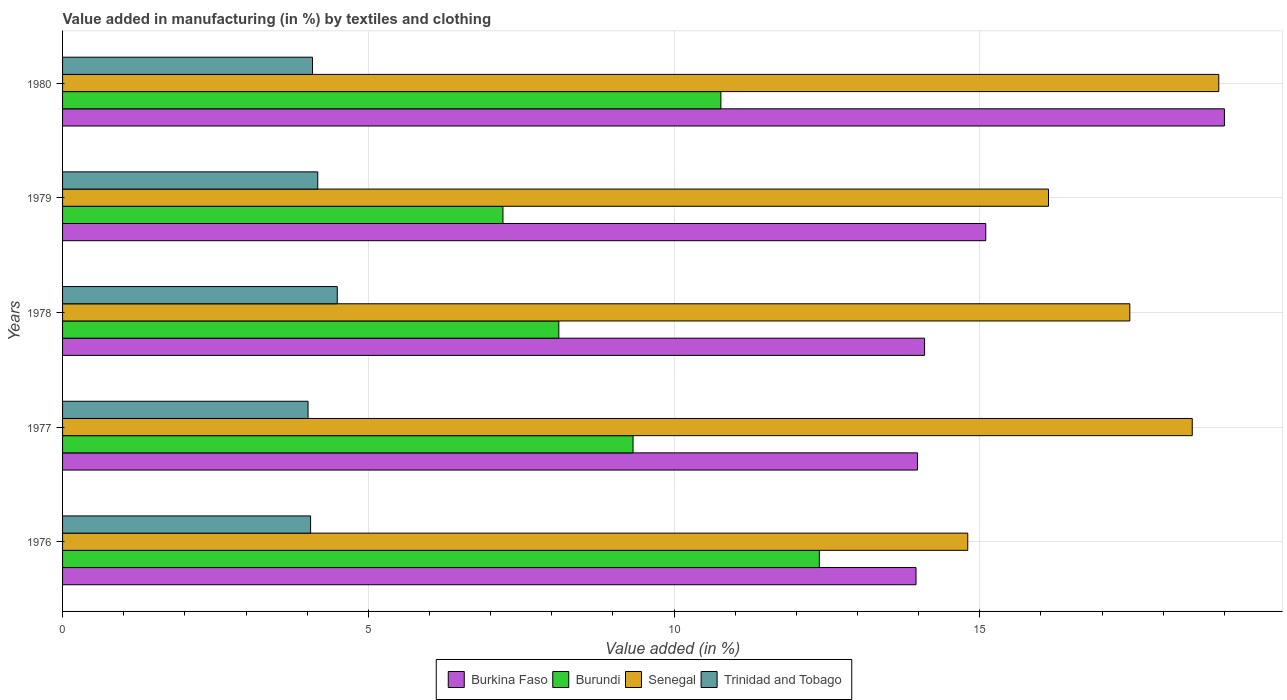How many different coloured bars are there?
Your answer should be compact. 4. Are the number of bars on each tick of the Y-axis equal?
Make the answer very short. Yes. How many bars are there on the 5th tick from the top?
Your response must be concise. 4. What is the label of the 2nd group of bars from the top?
Provide a short and direct response. 1979. In how many cases, is the number of bars for a given year not equal to the number of legend labels?
Your answer should be very brief. 0. What is the percentage of value added in manufacturing by textiles and clothing in Burundi in 1978?
Keep it short and to the point. 8.12. Across all years, what is the maximum percentage of value added in manufacturing by textiles and clothing in Burkina Faso?
Offer a terse response. 19. Across all years, what is the minimum percentage of value added in manufacturing by textiles and clothing in Burkina Faso?
Make the answer very short. 13.96. In which year was the percentage of value added in manufacturing by textiles and clothing in Burkina Faso minimum?
Provide a succinct answer. 1976. What is the total percentage of value added in manufacturing by textiles and clothing in Trinidad and Tobago in the graph?
Provide a short and direct response. 20.82. What is the difference between the percentage of value added in manufacturing by textiles and clothing in Burkina Faso in 1977 and that in 1978?
Make the answer very short. -0.12. What is the difference between the percentage of value added in manufacturing by textiles and clothing in Burkina Faso in 1979 and the percentage of value added in manufacturing by textiles and clothing in Trinidad and Tobago in 1977?
Your answer should be very brief. 11.08. What is the average percentage of value added in manufacturing by textiles and clothing in Burkina Faso per year?
Provide a short and direct response. 15.23. In the year 1978, what is the difference between the percentage of value added in manufacturing by textiles and clothing in Burkina Faso and percentage of value added in manufacturing by textiles and clothing in Trinidad and Tobago?
Give a very brief answer. 9.6. What is the ratio of the percentage of value added in manufacturing by textiles and clothing in Senegal in 1979 to that in 1980?
Keep it short and to the point. 0.85. Is the difference between the percentage of value added in manufacturing by textiles and clothing in Burkina Faso in 1977 and 1979 greater than the difference between the percentage of value added in manufacturing by textiles and clothing in Trinidad and Tobago in 1977 and 1979?
Offer a terse response. No. What is the difference between the highest and the second highest percentage of value added in manufacturing by textiles and clothing in Burundi?
Offer a very short reply. 1.61. What is the difference between the highest and the lowest percentage of value added in manufacturing by textiles and clothing in Burkina Faso?
Give a very brief answer. 5.04. Is the sum of the percentage of value added in manufacturing by textiles and clothing in Trinidad and Tobago in 1976 and 1977 greater than the maximum percentage of value added in manufacturing by textiles and clothing in Senegal across all years?
Provide a succinct answer. No. Is it the case that in every year, the sum of the percentage of value added in manufacturing by textiles and clothing in Trinidad and Tobago and percentage of value added in manufacturing by textiles and clothing in Burundi is greater than the sum of percentage of value added in manufacturing by textiles and clothing in Senegal and percentage of value added in manufacturing by textiles and clothing in Burkina Faso?
Ensure brevity in your answer.  Yes. What does the 4th bar from the top in 1978 represents?
Your answer should be compact. Burkina Faso. What does the 4th bar from the bottom in 1978 represents?
Provide a succinct answer. Trinidad and Tobago. Is it the case that in every year, the sum of the percentage of value added in manufacturing by textiles and clothing in Burundi and percentage of value added in manufacturing by textiles and clothing in Burkina Faso is greater than the percentage of value added in manufacturing by textiles and clothing in Trinidad and Tobago?
Offer a very short reply. Yes. How many bars are there?
Your response must be concise. 20. Are all the bars in the graph horizontal?
Ensure brevity in your answer.  Yes. What is the difference between two consecutive major ticks on the X-axis?
Ensure brevity in your answer.  5. Are the values on the major ticks of X-axis written in scientific E-notation?
Keep it short and to the point. No. Does the graph contain grids?
Your response must be concise. Yes. Where does the legend appear in the graph?
Offer a very short reply. Bottom center. What is the title of the graph?
Provide a short and direct response. Value added in manufacturing (in %) by textiles and clothing. What is the label or title of the X-axis?
Your answer should be very brief. Value added (in %). What is the label or title of the Y-axis?
Provide a short and direct response. Years. What is the Value added (in %) in Burkina Faso in 1976?
Offer a terse response. 13.96. What is the Value added (in %) in Burundi in 1976?
Your answer should be very brief. 12.38. What is the Value added (in %) in Senegal in 1976?
Offer a very short reply. 14.8. What is the Value added (in %) of Trinidad and Tobago in 1976?
Provide a short and direct response. 4.06. What is the Value added (in %) of Burkina Faso in 1977?
Keep it short and to the point. 13.98. What is the Value added (in %) of Burundi in 1977?
Your answer should be very brief. 9.33. What is the Value added (in %) of Senegal in 1977?
Make the answer very short. 18.48. What is the Value added (in %) of Trinidad and Tobago in 1977?
Offer a very short reply. 4.01. What is the Value added (in %) in Burkina Faso in 1978?
Offer a very short reply. 14.1. What is the Value added (in %) of Burundi in 1978?
Ensure brevity in your answer.  8.12. What is the Value added (in %) in Senegal in 1978?
Offer a terse response. 17.45. What is the Value added (in %) of Trinidad and Tobago in 1978?
Offer a terse response. 4.49. What is the Value added (in %) of Burkina Faso in 1979?
Offer a terse response. 15.1. What is the Value added (in %) in Burundi in 1979?
Give a very brief answer. 7.2. What is the Value added (in %) in Senegal in 1979?
Make the answer very short. 16.12. What is the Value added (in %) of Trinidad and Tobago in 1979?
Provide a short and direct response. 4.17. What is the Value added (in %) of Burkina Faso in 1980?
Your response must be concise. 19. What is the Value added (in %) of Burundi in 1980?
Make the answer very short. 10.77. What is the Value added (in %) in Senegal in 1980?
Provide a short and direct response. 18.91. What is the Value added (in %) of Trinidad and Tobago in 1980?
Your answer should be compact. 4.09. Across all years, what is the maximum Value added (in %) in Burkina Faso?
Make the answer very short. 19. Across all years, what is the maximum Value added (in %) in Burundi?
Provide a succinct answer. 12.38. Across all years, what is the maximum Value added (in %) of Senegal?
Ensure brevity in your answer.  18.91. Across all years, what is the maximum Value added (in %) in Trinidad and Tobago?
Ensure brevity in your answer.  4.49. Across all years, what is the minimum Value added (in %) of Burkina Faso?
Provide a succinct answer. 13.96. Across all years, what is the minimum Value added (in %) in Burundi?
Make the answer very short. 7.2. Across all years, what is the minimum Value added (in %) of Senegal?
Offer a terse response. 14.8. Across all years, what is the minimum Value added (in %) of Trinidad and Tobago?
Keep it short and to the point. 4.01. What is the total Value added (in %) of Burkina Faso in the graph?
Ensure brevity in your answer.  76.14. What is the total Value added (in %) of Burundi in the graph?
Give a very brief answer. 47.79. What is the total Value added (in %) in Senegal in the graph?
Provide a succinct answer. 85.77. What is the total Value added (in %) of Trinidad and Tobago in the graph?
Give a very brief answer. 20.82. What is the difference between the Value added (in %) in Burkina Faso in 1976 and that in 1977?
Your answer should be very brief. -0.02. What is the difference between the Value added (in %) in Burundi in 1976 and that in 1977?
Your answer should be compact. 3.05. What is the difference between the Value added (in %) in Senegal in 1976 and that in 1977?
Offer a very short reply. -3.67. What is the difference between the Value added (in %) of Trinidad and Tobago in 1976 and that in 1977?
Make the answer very short. 0.04. What is the difference between the Value added (in %) of Burkina Faso in 1976 and that in 1978?
Provide a short and direct response. -0.14. What is the difference between the Value added (in %) in Burundi in 1976 and that in 1978?
Offer a terse response. 4.26. What is the difference between the Value added (in %) in Senegal in 1976 and that in 1978?
Offer a terse response. -2.65. What is the difference between the Value added (in %) of Trinidad and Tobago in 1976 and that in 1978?
Give a very brief answer. -0.44. What is the difference between the Value added (in %) in Burkina Faso in 1976 and that in 1979?
Your answer should be compact. -1.14. What is the difference between the Value added (in %) in Burundi in 1976 and that in 1979?
Provide a short and direct response. 5.17. What is the difference between the Value added (in %) of Senegal in 1976 and that in 1979?
Offer a very short reply. -1.32. What is the difference between the Value added (in %) of Trinidad and Tobago in 1976 and that in 1979?
Give a very brief answer. -0.12. What is the difference between the Value added (in %) of Burkina Faso in 1976 and that in 1980?
Provide a short and direct response. -5.04. What is the difference between the Value added (in %) of Burundi in 1976 and that in 1980?
Ensure brevity in your answer.  1.61. What is the difference between the Value added (in %) of Senegal in 1976 and that in 1980?
Your answer should be compact. -4.11. What is the difference between the Value added (in %) in Trinidad and Tobago in 1976 and that in 1980?
Your answer should be compact. -0.03. What is the difference between the Value added (in %) in Burkina Faso in 1977 and that in 1978?
Ensure brevity in your answer.  -0.12. What is the difference between the Value added (in %) in Burundi in 1977 and that in 1978?
Provide a short and direct response. 1.21. What is the difference between the Value added (in %) in Senegal in 1977 and that in 1978?
Make the answer very short. 1.02. What is the difference between the Value added (in %) in Trinidad and Tobago in 1977 and that in 1978?
Make the answer very short. -0.48. What is the difference between the Value added (in %) of Burkina Faso in 1977 and that in 1979?
Provide a succinct answer. -1.12. What is the difference between the Value added (in %) of Burundi in 1977 and that in 1979?
Make the answer very short. 2.13. What is the difference between the Value added (in %) of Senegal in 1977 and that in 1979?
Provide a short and direct response. 2.35. What is the difference between the Value added (in %) in Trinidad and Tobago in 1977 and that in 1979?
Ensure brevity in your answer.  -0.16. What is the difference between the Value added (in %) of Burkina Faso in 1977 and that in 1980?
Make the answer very short. -5.02. What is the difference between the Value added (in %) in Burundi in 1977 and that in 1980?
Your answer should be very brief. -1.44. What is the difference between the Value added (in %) of Senegal in 1977 and that in 1980?
Your response must be concise. -0.43. What is the difference between the Value added (in %) of Trinidad and Tobago in 1977 and that in 1980?
Provide a succinct answer. -0.07. What is the difference between the Value added (in %) of Burkina Faso in 1978 and that in 1979?
Offer a terse response. -1. What is the difference between the Value added (in %) in Burundi in 1978 and that in 1979?
Give a very brief answer. 0.91. What is the difference between the Value added (in %) in Senegal in 1978 and that in 1979?
Your answer should be compact. 1.33. What is the difference between the Value added (in %) in Trinidad and Tobago in 1978 and that in 1979?
Give a very brief answer. 0.32. What is the difference between the Value added (in %) of Burkina Faso in 1978 and that in 1980?
Ensure brevity in your answer.  -4.9. What is the difference between the Value added (in %) of Burundi in 1978 and that in 1980?
Your answer should be compact. -2.65. What is the difference between the Value added (in %) of Senegal in 1978 and that in 1980?
Your answer should be very brief. -1.45. What is the difference between the Value added (in %) in Trinidad and Tobago in 1978 and that in 1980?
Keep it short and to the point. 0.41. What is the difference between the Value added (in %) in Burkina Faso in 1979 and that in 1980?
Keep it short and to the point. -3.9. What is the difference between the Value added (in %) in Burundi in 1979 and that in 1980?
Your answer should be very brief. -3.56. What is the difference between the Value added (in %) of Senegal in 1979 and that in 1980?
Keep it short and to the point. -2.78. What is the difference between the Value added (in %) in Trinidad and Tobago in 1979 and that in 1980?
Offer a terse response. 0.09. What is the difference between the Value added (in %) of Burkina Faso in 1976 and the Value added (in %) of Burundi in 1977?
Your answer should be very brief. 4.63. What is the difference between the Value added (in %) of Burkina Faso in 1976 and the Value added (in %) of Senegal in 1977?
Your response must be concise. -4.52. What is the difference between the Value added (in %) of Burkina Faso in 1976 and the Value added (in %) of Trinidad and Tobago in 1977?
Your answer should be very brief. 9.94. What is the difference between the Value added (in %) in Burundi in 1976 and the Value added (in %) in Senegal in 1977?
Your answer should be very brief. -6.1. What is the difference between the Value added (in %) in Burundi in 1976 and the Value added (in %) in Trinidad and Tobago in 1977?
Ensure brevity in your answer.  8.36. What is the difference between the Value added (in %) in Senegal in 1976 and the Value added (in %) in Trinidad and Tobago in 1977?
Offer a very short reply. 10.79. What is the difference between the Value added (in %) in Burkina Faso in 1976 and the Value added (in %) in Burundi in 1978?
Ensure brevity in your answer.  5.84. What is the difference between the Value added (in %) in Burkina Faso in 1976 and the Value added (in %) in Senegal in 1978?
Your answer should be very brief. -3.5. What is the difference between the Value added (in %) in Burkina Faso in 1976 and the Value added (in %) in Trinidad and Tobago in 1978?
Keep it short and to the point. 9.47. What is the difference between the Value added (in %) of Burundi in 1976 and the Value added (in %) of Senegal in 1978?
Provide a short and direct response. -5.08. What is the difference between the Value added (in %) of Burundi in 1976 and the Value added (in %) of Trinidad and Tobago in 1978?
Your answer should be very brief. 7.88. What is the difference between the Value added (in %) of Senegal in 1976 and the Value added (in %) of Trinidad and Tobago in 1978?
Keep it short and to the point. 10.31. What is the difference between the Value added (in %) of Burkina Faso in 1976 and the Value added (in %) of Burundi in 1979?
Give a very brief answer. 6.76. What is the difference between the Value added (in %) in Burkina Faso in 1976 and the Value added (in %) in Senegal in 1979?
Keep it short and to the point. -2.17. What is the difference between the Value added (in %) in Burkina Faso in 1976 and the Value added (in %) in Trinidad and Tobago in 1979?
Your answer should be compact. 9.78. What is the difference between the Value added (in %) in Burundi in 1976 and the Value added (in %) in Senegal in 1979?
Your response must be concise. -3.75. What is the difference between the Value added (in %) of Burundi in 1976 and the Value added (in %) of Trinidad and Tobago in 1979?
Your answer should be very brief. 8.2. What is the difference between the Value added (in %) of Senegal in 1976 and the Value added (in %) of Trinidad and Tobago in 1979?
Your answer should be compact. 10.63. What is the difference between the Value added (in %) of Burkina Faso in 1976 and the Value added (in %) of Burundi in 1980?
Ensure brevity in your answer.  3.19. What is the difference between the Value added (in %) in Burkina Faso in 1976 and the Value added (in %) in Senegal in 1980?
Give a very brief answer. -4.95. What is the difference between the Value added (in %) of Burkina Faso in 1976 and the Value added (in %) of Trinidad and Tobago in 1980?
Give a very brief answer. 9.87. What is the difference between the Value added (in %) of Burundi in 1976 and the Value added (in %) of Senegal in 1980?
Make the answer very short. -6.53. What is the difference between the Value added (in %) in Burundi in 1976 and the Value added (in %) in Trinidad and Tobago in 1980?
Offer a very short reply. 8.29. What is the difference between the Value added (in %) of Senegal in 1976 and the Value added (in %) of Trinidad and Tobago in 1980?
Your response must be concise. 10.72. What is the difference between the Value added (in %) of Burkina Faso in 1977 and the Value added (in %) of Burundi in 1978?
Ensure brevity in your answer.  5.87. What is the difference between the Value added (in %) of Burkina Faso in 1977 and the Value added (in %) of Senegal in 1978?
Your answer should be compact. -3.47. What is the difference between the Value added (in %) of Burkina Faso in 1977 and the Value added (in %) of Trinidad and Tobago in 1978?
Your answer should be compact. 9.49. What is the difference between the Value added (in %) of Burundi in 1977 and the Value added (in %) of Senegal in 1978?
Provide a succinct answer. -8.12. What is the difference between the Value added (in %) in Burundi in 1977 and the Value added (in %) in Trinidad and Tobago in 1978?
Your answer should be compact. 4.84. What is the difference between the Value added (in %) of Senegal in 1977 and the Value added (in %) of Trinidad and Tobago in 1978?
Keep it short and to the point. 13.98. What is the difference between the Value added (in %) of Burkina Faso in 1977 and the Value added (in %) of Burundi in 1979?
Provide a succinct answer. 6.78. What is the difference between the Value added (in %) in Burkina Faso in 1977 and the Value added (in %) in Senegal in 1979?
Give a very brief answer. -2.14. What is the difference between the Value added (in %) of Burkina Faso in 1977 and the Value added (in %) of Trinidad and Tobago in 1979?
Your response must be concise. 9.81. What is the difference between the Value added (in %) in Burundi in 1977 and the Value added (in %) in Senegal in 1979?
Your response must be concise. -6.79. What is the difference between the Value added (in %) of Burundi in 1977 and the Value added (in %) of Trinidad and Tobago in 1979?
Make the answer very short. 5.16. What is the difference between the Value added (in %) of Senegal in 1977 and the Value added (in %) of Trinidad and Tobago in 1979?
Your answer should be very brief. 14.3. What is the difference between the Value added (in %) of Burkina Faso in 1977 and the Value added (in %) of Burundi in 1980?
Keep it short and to the point. 3.22. What is the difference between the Value added (in %) of Burkina Faso in 1977 and the Value added (in %) of Senegal in 1980?
Your answer should be very brief. -4.93. What is the difference between the Value added (in %) of Burkina Faso in 1977 and the Value added (in %) of Trinidad and Tobago in 1980?
Offer a terse response. 9.89. What is the difference between the Value added (in %) of Burundi in 1977 and the Value added (in %) of Senegal in 1980?
Keep it short and to the point. -9.58. What is the difference between the Value added (in %) in Burundi in 1977 and the Value added (in %) in Trinidad and Tobago in 1980?
Your answer should be very brief. 5.24. What is the difference between the Value added (in %) in Senegal in 1977 and the Value added (in %) in Trinidad and Tobago in 1980?
Offer a terse response. 14.39. What is the difference between the Value added (in %) of Burkina Faso in 1978 and the Value added (in %) of Burundi in 1979?
Ensure brevity in your answer.  6.9. What is the difference between the Value added (in %) of Burkina Faso in 1978 and the Value added (in %) of Senegal in 1979?
Offer a terse response. -2.03. What is the difference between the Value added (in %) of Burkina Faso in 1978 and the Value added (in %) of Trinidad and Tobago in 1979?
Make the answer very short. 9.92. What is the difference between the Value added (in %) of Burundi in 1978 and the Value added (in %) of Senegal in 1979?
Offer a very short reply. -8.01. What is the difference between the Value added (in %) in Burundi in 1978 and the Value added (in %) in Trinidad and Tobago in 1979?
Your answer should be very brief. 3.94. What is the difference between the Value added (in %) of Senegal in 1978 and the Value added (in %) of Trinidad and Tobago in 1979?
Offer a very short reply. 13.28. What is the difference between the Value added (in %) in Burkina Faso in 1978 and the Value added (in %) in Burundi in 1980?
Your answer should be very brief. 3.33. What is the difference between the Value added (in %) in Burkina Faso in 1978 and the Value added (in %) in Senegal in 1980?
Your answer should be very brief. -4.81. What is the difference between the Value added (in %) in Burkina Faso in 1978 and the Value added (in %) in Trinidad and Tobago in 1980?
Your response must be concise. 10.01. What is the difference between the Value added (in %) in Burundi in 1978 and the Value added (in %) in Senegal in 1980?
Offer a terse response. -10.79. What is the difference between the Value added (in %) in Burundi in 1978 and the Value added (in %) in Trinidad and Tobago in 1980?
Provide a short and direct response. 4.03. What is the difference between the Value added (in %) in Senegal in 1978 and the Value added (in %) in Trinidad and Tobago in 1980?
Your response must be concise. 13.37. What is the difference between the Value added (in %) in Burkina Faso in 1979 and the Value added (in %) in Burundi in 1980?
Provide a short and direct response. 4.33. What is the difference between the Value added (in %) in Burkina Faso in 1979 and the Value added (in %) in Senegal in 1980?
Offer a terse response. -3.81. What is the difference between the Value added (in %) of Burkina Faso in 1979 and the Value added (in %) of Trinidad and Tobago in 1980?
Provide a succinct answer. 11.01. What is the difference between the Value added (in %) in Burundi in 1979 and the Value added (in %) in Senegal in 1980?
Keep it short and to the point. -11.71. What is the difference between the Value added (in %) in Burundi in 1979 and the Value added (in %) in Trinidad and Tobago in 1980?
Keep it short and to the point. 3.12. What is the difference between the Value added (in %) of Senegal in 1979 and the Value added (in %) of Trinidad and Tobago in 1980?
Provide a succinct answer. 12.04. What is the average Value added (in %) of Burkina Faso per year?
Offer a terse response. 15.23. What is the average Value added (in %) of Burundi per year?
Provide a succinct answer. 9.56. What is the average Value added (in %) of Senegal per year?
Your answer should be compact. 17.15. What is the average Value added (in %) of Trinidad and Tobago per year?
Your response must be concise. 4.16. In the year 1976, what is the difference between the Value added (in %) of Burkina Faso and Value added (in %) of Burundi?
Make the answer very short. 1.58. In the year 1976, what is the difference between the Value added (in %) in Burkina Faso and Value added (in %) in Senegal?
Keep it short and to the point. -0.85. In the year 1976, what is the difference between the Value added (in %) in Burkina Faso and Value added (in %) in Trinidad and Tobago?
Your response must be concise. 9.9. In the year 1976, what is the difference between the Value added (in %) in Burundi and Value added (in %) in Senegal?
Offer a terse response. -2.43. In the year 1976, what is the difference between the Value added (in %) of Burundi and Value added (in %) of Trinidad and Tobago?
Provide a succinct answer. 8.32. In the year 1976, what is the difference between the Value added (in %) in Senegal and Value added (in %) in Trinidad and Tobago?
Provide a succinct answer. 10.75. In the year 1977, what is the difference between the Value added (in %) of Burkina Faso and Value added (in %) of Burundi?
Your answer should be compact. 4.65. In the year 1977, what is the difference between the Value added (in %) of Burkina Faso and Value added (in %) of Senegal?
Offer a very short reply. -4.49. In the year 1977, what is the difference between the Value added (in %) in Burkina Faso and Value added (in %) in Trinidad and Tobago?
Offer a terse response. 9.97. In the year 1977, what is the difference between the Value added (in %) of Burundi and Value added (in %) of Senegal?
Offer a terse response. -9.15. In the year 1977, what is the difference between the Value added (in %) of Burundi and Value added (in %) of Trinidad and Tobago?
Give a very brief answer. 5.32. In the year 1977, what is the difference between the Value added (in %) of Senegal and Value added (in %) of Trinidad and Tobago?
Your answer should be compact. 14.46. In the year 1978, what is the difference between the Value added (in %) in Burkina Faso and Value added (in %) in Burundi?
Provide a short and direct response. 5.98. In the year 1978, what is the difference between the Value added (in %) in Burkina Faso and Value added (in %) in Senegal?
Your answer should be very brief. -3.36. In the year 1978, what is the difference between the Value added (in %) of Burkina Faso and Value added (in %) of Trinidad and Tobago?
Give a very brief answer. 9.61. In the year 1978, what is the difference between the Value added (in %) of Burundi and Value added (in %) of Senegal?
Your response must be concise. -9.34. In the year 1978, what is the difference between the Value added (in %) of Burundi and Value added (in %) of Trinidad and Tobago?
Provide a short and direct response. 3.62. In the year 1978, what is the difference between the Value added (in %) in Senegal and Value added (in %) in Trinidad and Tobago?
Your response must be concise. 12.96. In the year 1979, what is the difference between the Value added (in %) in Burkina Faso and Value added (in %) in Burundi?
Your answer should be very brief. 7.9. In the year 1979, what is the difference between the Value added (in %) in Burkina Faso and Value added (in %) in Senegal?
Your answer should be very brief. -1.03. In the year 1979, what is the difference between the Value added (in %) in Burkina Faso and Value added (in %) in Trinidad and Tobago?
Give a very brief answer. 10.92. In the year 1979, what is the difference between the Value added (in %) in Burundi and Value added (in %) in Senegal?
Keep it short and to the point. -8.92. In the year 1979, what is the difference between the Value added (in %) in Burundi and Value added (in %) in Trinidad and Tobago?
Make the answer very short. 3.03. In the year 1979, what is the difference between the Value added (in %) in Senegal and Value added (in %) in Trinidad and Tobago?
Your answer should be very brief. 11.95. In the year 1980, what is the difference between the Value added (in %) in Burkina Faso and Value added (in %) in Burundi?
Provide a short and direct response. 8.23. In the year 1980, what is the difference between the Value added (in %) in Burkina Faso and Value added (in %) in Senegal?
Your answer should be compact. 0.09. In the year 1980, what is the difference between the Value added (in %) of Burkina Faso and Value added (in %) of Trinidad and Tobago?
Your response must be concise. 14.91. In the year 1980, what is the difference between the Value added (in %) of Burundi and Value added (in %) of Senegal?
Provide a succinct answer. -8.14. In the year 1980, what is the difference between the Value added (in %) of Burundi and Value added (in %) of Trinidad and Tobago?
Ensure brevity in your answer.  6.68. In the year 1980, what is the difference between the Value added (in %) in Senegal and Value added (in %) in Trinidad and Tobago?
Make the answer very short. 14.82. What is the ratio of the Value added (in %) of Burundi in 1976 to that in 1977?
Provide a short and direct response. 1.33. What is the ratio of the Value added (in %) in Senegal in 1976 to that in 1977?
Your response must be concise. 0.8. What is the ratio of the Value added (in %) of Trinidad and Tobago in 1976 to that in 1977?
Provide a succinct answer. 1.01. What is the ratio of the Value added (in %) of Burundi in 1976 to that in 1978?
Your response must be concise. 1.52. What is the ratio of the Value added (in %) in Senegal in 1976 to that in 1978?
Offer a very short reply. 0.85. What is the ratio of the Value added (in %) in Trinidad and Tobago in 1976 to that in 1978?
Your answer should be compact. 0.9. What is the ratio of the Value added (in %) in Burkina Faso in 1976 to that in 1979?
Offer a very short reply. 0.92. What is the ratio of the Value added (in %) in Burundi in 1976 to that in 1979?
Your response must be concise. 1.72. What is the ratio of the Value added (in %) in Senegal in 1976 to that in 1979?
Provide a succinct answer. 0.92. What is the ratio of the Value added (in %) of Trinidad and Tobago in 1976 to that in 1979?
Your answer should be very brief. 0.97. What is the ratio of the Value added (in %) in Burkina Faso in 1976 to that in 1980?
Provide a short and direct response. 0.73. What is the ratio of the Value added (in %) in Burundi in 1976 to that in 1980?
Your answer should be very brief. 1.15. What is the ratio of the Value added (in %) in Senegal in 1976 to that in 1980?
Make the answer very short. 0.78. What is the ratio of the Value added (in %) of Burkina Faso in 1977 to that in 1978?
Offer a terse response. 0.99. What is the ratio of the Value added (in %) in Burundi in 1977 to that in 1978?
Make the answer very short. 1.15. What is the ratio of the Value added (in %) in Senegal in 1977 to that in 1978?
Give a very brief answer. 1.06. What is the ratio of the Value added (in %) of Trinidad and Tobago in 1977 to that in 1978?
Give a very brief answer. 0.89. What is the ratio of the Value added (in %) in Burkina Faso in 1977 to that in 1979?
Your answer should be very brief. 0.93. What is the ratio of the Value added (in %) of Burundi in 1977 to that in 1979?
Your answer should be very brief. 1.3. What is the ratio of the Value added (in %) of Senegal in 1977 to that in 1979?
Give a very brief answer. 1.15. What is the ratio of the Value added (in %) in Trinidad and Tobago in 1977 to that in 1979?
Your answer should be very brief. 0.96. What is the ratio of the Value added (in %) in Burkina Faso in 1977 to that in 1980?
Your response must be concise. 0.74. What is the ratio of the Value added (in %) of Burundi in 1977 to that in 1980?
Give a very brief answer. 0.87. What is the ratio of the Value added (in %) in Trinidad and Tobago in 1977 to that in 1980?
Keep it short and to the point. 0.98. What is the ratio of the Value added (in %) in Burkina Faso in 1978 to that in 1979?
Your answer should be compact. 0.93. What is the ratio of the Value added (in %) of Burundi in 1978 to that in 1979?
Your answer should be very brief. 1.13. What is the ratio of the Value added (in %) in Senegal in 1978 to that in 1979?
Your answer should be compact. 1.08. What is the ratio of the Value added (in %) in Trinidad and Tobago in 1978 to that in 1979?
Provide a succinct answer. 1.08. What is the ratio of the Value added (in %) of Burkina Faso in 1978 to that in 1980?
Ensure brevity in your answer.  0.74. What is the ratio of the Value added (in %) in Burundi in 1978 to that in 1980?
Offer a very short reply. 0.75. What is the ratio of the Value added (in %) of Trinidad and Tobago in 1978 to that in 1980?
Your answer should be very brief. 1.1. What is the ratio of the Value added (in %) of Burkina Faso in 1979 to that in 1980?
Ensure brevity in your answer.  0.79. What is the ratio of the Value added (in %) of Burundi in 1979 to that in 1980?
Your answer should be very brief. 0.67. What is the ratio of the Value added (in %) of Senegal in 1979 to that in 1980?
Ensure brevity in your answer.  0.85. What is the ratio of the Value added (in %) in Trinidad and Tobago in 1979 to that in 1980?
Provide a short and direct response. 1.02. What is the difference between the highest and the second highest Value added (in %) of Burkina Faso?
Your answer should be compact. 3.9. What is the difference between the highest and the second highest Value added (in %) of Burundi?
Give a very brief answer. 1.61. What is the difference between the highest and the second highest Value added (in %) in Senegal?
Ensure brevity in your answer.  0.43. What is the difference between the highest and the second highest Value added (in %) in Trinidad and Tobago?
Ensure brevity in your answer.  0.32. What is the difference between the highest and the lowest Value added (in %) of Burkina Faso?
Provide a succinct answer. 5.04. What is the difference between the highest and the lowest Value added (in %) of Burundi?
Offer a terse response. 5.17. What is the difference between the highest and the lowest Value added (in %) in Senegal?
Offer a terse response. 4.11. What is the difference between the highest and the lowest Value added (in %) in Trinidad and Tobago?
Offer a very short reply. 0.48. 